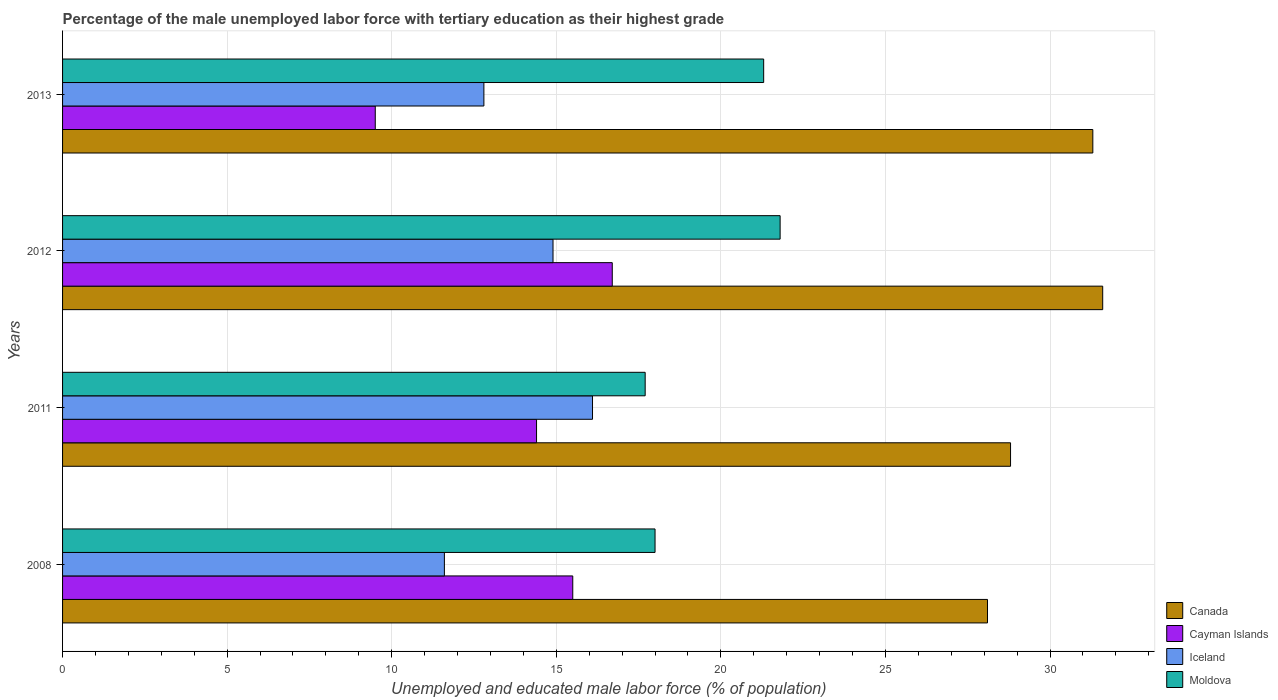How many different coloured bars are there?
Provide a succinct answer. 4. How many groups of bars are there?
Provide a short and direct response. 4. Are the number of bars on each tick of the Y-axis equal?
Keep it short and to the point. Yes. What is the label of the 2nd group of bars from the top?
Your answer should be compact. 2012. In how many cases, is the number of bars for a given year not equal to the number of legend labels?
Your answer should be very brief. 0. What is the percentage of the unemployed male labor force with tertiary education in Cayman Islands in 2013?
Your answer should be very brief. 9.5. Across all years, what is the maximum percentage of the unemployed male labor force with tertiary education in Moldova?
Give a very brief answer. 21.8. What is the total percentage of the unemployed male labor force with tertiary education in Iceland in the graph?
Your answer should be very brief. 55.4. What is the difference between the percentage of the unemployed male labor force with tertiary education in Cayman Islands in 2011 and that in 2012?
Offer a terse response. -2.3. What is the difference between the percentage of the unemployed male labor force with tertiary education in Canada in 2011 and the percentage of the unemployed male labor force with tertiary education in Cayman Islands in 2012?
Give a very brief answer. 12.1. What is the average percentage of the unemployed male labor force with tertiary education in Cayman Islands per year?
Make the answer very short. 14.03. In the year 2013, what is the difference between the percentage of the unemployed male labor force with tertiary education in Iceland and percentage of the unemployed male labor force with tertiary education in Canada?
Provide a short and direct response. -18.5. In how many years, is the percentage of the unemployed male labor force with tertiary education in Moldova greater than 7 %?
Offer a very short reply. 4. What is the ratio of the percentage of the unemployed male labor force with tertiary education in Cayman Islands in 2012 to that in 2013?
Your answer should be compact. 1.76. Is the difference between the percentage of the unemployed male labor force with tertiary education in Iceland in 2011 and 2012 greater than the difference between the percentage of the unemployed male labor force with tertiary education in Canada in 2011 and 2012?
Provide a succinct answer. Yes. What is the difference between the highest and the second highest percentage of the unemployed male labor force with tertiary education in Cayman Islands?
Provide a succinct answer. 1.2. What is the difference between the highest and the lowest percentage of the unemployed male labor force with tertiary education in Moldova?
Your response must be concise. 4.1. In how many years, is the percentage of the unemployed male labor force with tertiary education in Canada greater than the average percentage of the unemployed male labor force with tertiary education in Canada taken over all years?
Offer a very short reply. 2. What does the 3rd bar from the top in 2013 represents?
Give a very brief answer. Cayman Islands. What does the 4th bar from the bottom in 2008 represents?
Your answer should be very brief. Moldova. Is it the case that in every year, the sum of the percentage of the unemployed male labor force with tertiary education in Moldova and percentage of the unemployed male labor force with tertiary education in Iceland is greater than the percentage of the unemployed male labor force with tertiary education in Canada?
Your answer should be very brief. Yes. How many bars are there?
Your answer should be very brief. 16. How many years are there in the graph?
Offer a terse response. 4. What is the difference between two consecutive major ticks on the X-axis?
Give a very brief answer. 5. Does the graph contain grids?
Your response must be concise. Yes. How many legend labels are there?
Provide a succinct answer. 4. What is the title of the graph?
Your response must be concise. Percentage of the male unemployed labor force with tertiary education as their highest grade. Does "Botswana" appear as one of the legend labels in the graph?
Offer a very short reply. No. What is the label or title of the X-axis?
Offer a very short reply. Unemployed and educated male labor force (% of population). What is the label or title of the Y-axis?
Your answer should be compact. Years. What is the Unemployed and educated male labor force (% of population) of Canada in 2008?
Ensure brevity in your answer.  28.1. What is the Unemployed and educated male labor force (% of population) in Cayman Islands in 2008?
Offer a very short reply. 15.5. What is the Unemployed and educated male labor force (% of population) of Iceland in 2008?
Your answer should be compact. 11.6. What is the Unemployed and educated male labor force (% of population) of Moldova in 2008?
Your response must be concise. 18. What is the Unemployed and educated male labor force (% of population) of Canada in 2011?
Give a very brief answer. 28.8. What is the Unemployed and educated male labor force (% of population) of Cayman Islands in 2011?
Offer a very short reply. 14.4. What is the Unemployed and educated male labor force (% of population) in Iceland in 2011?
Ensure brevity in your answer.  16.1. What is the Unemployed and educated male labor force (% of population) of Moldova in 2011?
Offer a terse response. 17.7. What is the Unemployed and educated male labor force (% of population) in Canada in 2012?
Keep it short and to the point. 31.6. What is the Unemployed and educated male labor force (% of population) in Cayman Islands in 2012?
Your answer should be compact. 16.7. What is the Unemployed and educated male labor force (% of population) in Iceland in 2012?
Offer a terse response. 14.9. What is the Unemployed and educated male labor force (% of population) in Moldova in 2012?
Your response must be concise. 21.8. What is the Unemployed and educated male labor force (% of population) of Canada in 2013?
Offer a terse response. 31.3. What is the Unemployed and educated male labor force (% of population) of Iceland in 2013?
Your answer should be very brief. 12.8. What is the Unemployed and educated male labor force (% of population) of Moldova in 2013?
Give a very brief answer. 21.3. Across all years, what is the maximum Unemployed and educated male labor force (% of population) in Canada?
Keep it short and to the point. 31.6. Across all years, what is the maximum Unemployed and educated male labor force (% of population) of Cayman Islands?
Make the answer very short. 16.7. Across all years, what is the maximum Unemployed and educated male labor force (% of population) in Iceland?
Ensure brevity in your answer.  16.1. Across all years, what is the maximum Unemployed and educated male labor force (% of population) of Moldova?
Your answer should be very brief. 21.8. Across all years, what is the minimum Unemployed and educated male labor force (% of population) in Canada?
Provide a short and direct response. 28.1. Across all years, what is the minimum Unemployed and educated male labor force (% of population) of Cayman Islands?
Offer a terse response. 9.5. Across all years, what is the minimum Unemployed and educated male labor force (% of population) in Iceland?
Your answer should be very brief. 11.6. Across all years, what is the minimum Unemployed and educated male labor force (% of population) in Moldova?
Offer a terse response. 17.7. What is the total Unemployed and educated male labor force (% of population) of Canada in the graph?
Make the answer very short. 119.8. What is the total Unemployed and educated male labor force (% of population) of Cayman Islands in the graph?
Provide a succinct answer. 56.1. What is the total Unemployed and educated male labor force (% of population) in Iceland in the graph?
Ensure brevity in your answer.  55.4. What is the total Unemployed and educated male labor force (% of population) of Moldova in the graph?
Your answer should be very brief. 78.8. What is the difference between the Unemployed and educated male labor force (% of population) in Cayman Islands in 2008 and that in 2011?
Provide a succinct answer. 1.1. What is the difference between the Unemployed and educated male labor force (% of population) in Iceland in 2008 and that in 2012?
Your answer should be compact. -3.3. What is the difference between the Unemployed and educated male labor force (% of population) of Moldova in 2008 and that in 2012?
Provide a short and direct response. -3.8. What is the difference between the Unemployed and educated male labor force (% of population) in Iceland in 2008 and that in 2013?
Give a very brief answer. -1.2. What is the difference between the Unemployed and educated male labor force (% of population) in Moldova in 2008 and that in 2013?
Make the answer very short. -3.3. What is the difference between the Unemployed and educated male labor force (% of population) in Cayman Islands in 2011 and that in 2012?
Provide a short and direct response. -2.3. What is the difference between the Unemployed and educated male labor force (% of population) of Iceland in 2011 and that in 2012?
Your answer should be compact. 1.2. What is the difference between the Unemployed and educated male labor force (% of population) in Canada in 2011 and that in 2013?
Give a very brief answer. -2.5. What is the difference between the Unemployed and educated male labor force (% of population) of Canada in 2012 and that in 2013?
Offer a very short reply. 0.3. What is the difference between the Unemployed and educated male labor force (% of population) of Cayman Islands in 2012 and that in 2013?
Keep it short and to the point. 7.2. What is the difference between the Unemployed and educated male labor force (% of population) in Moldova in 2012 and that in 2013?
Provide a succinct answer. 0.5. What is the difference between the Unemployed and educated male labor force (% of population) in Canada in 2008 and the Unemployed and educated male labor force (% of population) in Iceland in 2011?
Your response must be concise. 12. What is the difference between the Unemployed and educated male labor force (% of population) in Iceland in 2008 and the Unemployed and educated male labor force (% of population) in Moldova in 2011?
Your answer should be compact. -6.1. What is the difference between the Unemployed and educated male labor force (% of population) of Canada in 2008 and the Unemployed and educated male labor force (% of population) of Cayman Islands in 2012?
Your response must be concise. 11.4. What is the difference between the Unemployed and educated male labor force (% of population) of Iceland in 2008 and the Unemployed and educated male labor force (% of population) of Moldova in 2012?
Ensure brevity in your answer.  -10.2. What is the difference between the Unemployed and educated male labor force (% of population) of Canada in 2008 and the Unemployed and educated male labor force (% of population) of Cayman Islands in 2013?
Keep it short and to the point. 18.6. What is the difference between the Unemployed and educated male labor force (% of population) of Cayman Islands in 2008 and the Unemployed and educated male labor force (% of population) of Iceland in 2013?
Your answer should be very brief. 2.7. What is the difference between the Unemployed and educated male labor force (% of population) in Cayman Islands in 2008 and the Unemployed and educated male labor force (% of population) in Moldova in 2013?
Your answer should be very brief. -5.8. What is the difference between the Unemployed and educated male labor force (% of population) in Iceland in 2008 and the Unemployed and educated male labor force (% of population) in Moldova in 2013?
Your response must be concise. -9.7. What is the difference between the Unemployed and educated male labor force (% of population) of Canada in 2011 and the Unemployed and educated male labor force (% of population) of Cayman Islands in 2012?
Your response must be concise. 12.1. What is the difference between the Unemployed and educated male labor force (% of population) in Canada in 2011 and the Unemployed and educated male labor force (% of population) in Cayman Islands in 2013?
Give a very brief answer. 19.3. What is the difference between the Unemployed and educated male labor force (% of population) of Canada in 2011 and the Unemployed and educated male labor force (% of population) of Moldova in 2013?
Keep it short and to the point. 7.5. What is the difference between the Unemployed and educated male labor force (% of population) in Cayman Islands in 2011 and the Unemployed and educated male labor force (% of population) in Iceland in 2013?
Offer a terse response. 1.6. What is the difference between the Unemployed and educated male labor force (% of population) of Canada in 2012 and the Unemployed and educated male labor force (% of population) of Cayman Islands in 2013?
Your answer should be very brief. 22.1. What is the difference between the Unemployed and educated male labor force (% of population) in Cayman Islands in 2012 and the Unemployed and educated male labor force (% of population) in Iceland in 2013?
Provide a short and direct response. 3.9. What is the difference between the Unemployed and educated male labor force (% of population) in Cayman Islands in 2012 and the Unemployed and educated male labor force (% of population) in Moldova in 2013?
Your answer should be compact. -4.6. What is the difference between the Unemployed and educated male labor force (% of population) of Iceland in 2012 and the Unemployed and educated male labor force (% of population) of Moldova in 2013?
Provide a succinct answer. -6.4. What is the average Unemployed and educated male labor force (% of population) in Canada per year?
Ensure brevity in your answer.  29.95. What is the average Unemployed and educated male labor force (% of population) in Cayman Islands per year?
Your answer should be very brief. 14.03. What is the average Unemployed and educated male labor force (% of population) of Iceland per year?
Offer a very short reply. 13.85. In the year 2008, what is the difference between the Unemployed and educated male labor force (% of population) in Canada and Unemployed and educated male labor force (% of population) in Cayman Islands?
Keep it short and to the point. 12.6. In the year 2008, what is the difference between the Unemployed and educated male labor force (% of population) of Cayman Islands and Unemployed and educated male labor force (% of population) of Moldova?
Make the answer very short. -2.5. In the year 2008, what is the difference between the Unemployed and educated male labor force (% of population) in Iceland and Unemployed and educated male labor force (% of population) in Moldova?
Keep it short and to the point. -6.4. In the year 2011, what is the difference between the Unemployed and educated male labor force (% of population) in Canada and Unemployed and educated male labor force (% of population) in Cayman Islands?
Offer a terse response. 14.4. In the year 2011, what is the difference between the Unemployed and educated male labor force (% of population) in Canada and Unemployed and educated male labor force (% of population) in Iceland?
Make the answer very short. 12.7. In the year 2011, what is the difference between the Unemployed and educated male labor force (% of population) in Iceland and Unemployed and educated male labor force (% of population) in Moldova?
Your answer should be very brief. -1.6. In the year 2012, what is the difference between the Unemployed and educated male labor force (% of population) of Canada and Unemployed and educated male labor force (% of population) of Cayman Islands?
Keep it short and to the point. 14.9. In the year 2012, what is the difference between the Unemployed and educated male labor force (% of population) in Cayman Islands and Unemployed and educated male labor force (% of population) in Iceland?
Give a very brief answer. 1.8. In the year 2013, what is the difference between the Unemployed and educated male labor force (% of population) of Canada and Unemployed and educated male labor force (% of population) of Cayman Islands?
Your answer should be compact. 21.8. In the year 2013, what is the difference between the Unemployed and educated male labor force (% of population) of Cayman Islands and Unemployed and educated male labor force (% of population) of Moldova?
Ensure brevity in your answer.  -11.8. In the year 2013, what is the difference between the Unemployed and educated male labor force (% of population) of Iceland and Unemployed and educated male labor force (% of population) of Moldova?
Keep it short and to the point. -8.5. What is the ratio of the Unemployed and educated male labor force (% of population) in Canada in 2008 to that in 2011?
Give a very brief answer. 0.98. What is the ratio of the Unemployed and educated male labor force (% of population) of Cayman Islands in 2008 to that in 2011?
Offer a terse response. 1.08. What is the ratio of the Unemployed and educated male labor force (% of population) in Iceland in 2008 to that in 2011?
Provide a short and direct response. 0.72. What is the ratio of the Unemployed and educated male labor force (% of population) of Moldova in 2008 to that in 2011?
Offer a terse response. 1.02. What is the ratio of the Unemployed and educated male labor force (% of population) in Canada in 2008 to that in 2012?
Provide a succinct answer. 0.89. What is the ratio of the Unemployed and educated male labor force (% of population) of Cayman Islands in 2008 to that in 2012?
Offer a very short reply. 0.93. What is the ratio of the Unemployed and educated male labor force (% of population) in Iceland in 2008 to that in 2012?
Offer a terse response. 0.78. What is the ratio of the Unemployed and educated male labor force (% of population) of Moldova in 2008 to that in 2012?
Your response must be concise. 0.83. What is the ratio of the Unemployed and educated male labor force (% of population) in Canada in 2008 to that in 2013?
Your answer should be very brief. 0.9. What is the ratio of the Unemployed and educated male labor force (% of population) in Cayman Islands in 2008 to that in 2013?
Make the answer very short. 1.63. What is the ratio of the Unemployed and educated male labor force (% of population) in Iceland in 2008 to that in 2013?
Keep it short and to the point. 0.91. What is the ratio of the Unemployed and educated male labor force (% of population) in Moldova in 2008 to that in 2013?
Offer a terse response. 0.85. What is the ratio of the Unemployed and educated male labor force (% of population) in Canada in 2011 to that in 2012?
Offer a very short reply. 0.91. What is the ratio of the Unemployed and educated male labor force (% of population) in Cayman Islands in 2011 to that in 2012?
Your answer should be very brief. 0.86. What is the ratio of the Unemployed and educated male labor force (% of population) in Iceland in 2011 to that in 2012?
Keep it short and to the point. 1.08. What is the ratio of the Unemployed and educated male labor force (% of population) in Moldova in 2011 to that in 2012?
Your answer should be compact. 0.81. What is the ratio of the Unemployed and educated male labor force (% of population) in Canada in 2011 to that in 2013?
Your answer should be very brief. 0.92. What is the ratio of the Unemployed and educated male labor force (% of population) of Cayman Islands in 2011 to that in 2013?
Offer a very short reply. 1.52. What is the ratio of the Unemployed and educated male labor force (% of population) in Iceland in 2011 to that in 2013?
Your answer should be very brief. 1.26. What is the ratio of the Unemployed and educated male labor force (% of population) of Moldova in 2011 to that in 2013?
Offer a very short reply. 0.83. What is the ratio of the Unemployed and educated male labor force (% of population) in Canada in 2012 to that in 2013?
Give a very brief answer. 1.01. What is the ratio of the Unemployed and educated male labor force (% of population) of Cayman Islands in 2012 to that in 2013?
Offer a terse response. 1.76. What is the ratio of the Unemployed and educated male labor force (% of population) of Iceland in 2012 to that in 2013?
Give a very brief answer. 1.16. What is the ratio of the Unemployed and educated male labor force (% of population) of Moldova in 2012 to that in 2013?
Your answer should be very brief. 1.02. What is the difference between the highest and the second highest Unemployed and educated male labor force (% of population) in Cayman Islands?
Your answer should be very brief. 1.2. What is the difference between the highest and the second highest Unemployed and educated male labor force (% of population) in Iceland?
Keep it short and to the point. 1.2. What is the difference between the highest and the second highest Unemployed and educated male labor force (% of population) in Moldova?
Keep it short and to the point. 0.5. What is the difference between the highest and the lowest Unemployed and educated male labor force (% of population) in Iceland?
Your answer should be compact. 4.5. What is the difference between the highest and the lowest Unemployed and educated male labor force (% of population) of Moldova?
Give a very brief answer. 4.1. 